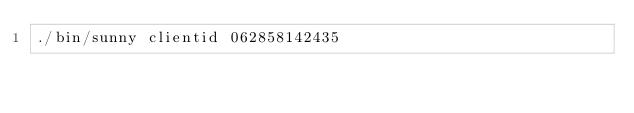<code> <loc_0><loc_0><loc_500><loc_500><_Bash_>./bin/sunny clientid 062858142435</code> 